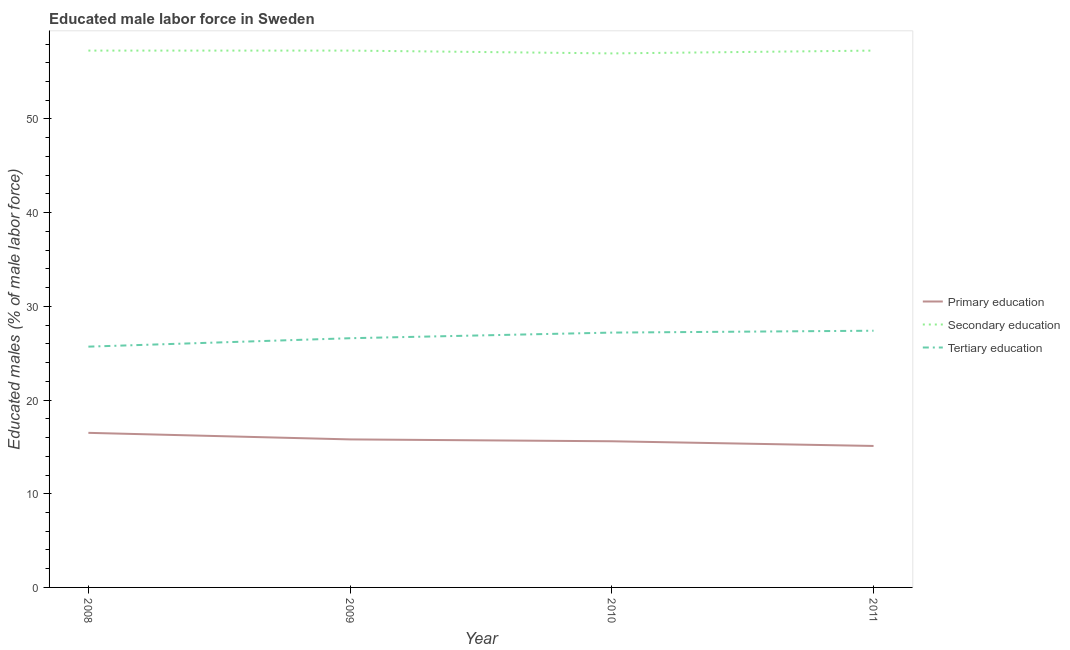Does the line corresponding to percentage of male labor force who received secondary education intersect with the line corresponding to percentage of male labor force who received primary education?
Offer a terse response. No. What is the percentage of male labor force who received secondary education in 2011?
Keep it short and to the point. 57.3. Across all years, what is the minimum percentage of male labor force who received primary education?
Your answer should be very brief. 15.1. In which year was the percentage of male labor force who received tertiary education maximum?
Offer a very short reply. 2011. In which year was the percentage of male labor force who received tertiary education minimum?
Keep it short and to the point. 2008. What is the total percentage of male labor force who received secondary education in the graph?
Offer a very short reply. 228.9. What is the difference between the percentage of male labor force who received secondary education in 2009 and that in 2010?
Provide a succinct answer. 0.3. What is the difference between the percentage of male labor force who received tertiary education in 2008 and the percentage of male labor force who received primary education in 2009?
Keep it short and to the point. 9.9. What is the average percentage of male labor force who received tertiary education per year?
Ensure brevity in your answer.  26.73. In the year 2010, what is the difference between the percentage of male labor force who received tertiary education and percentage of male labor force who received primary education?
Give a very brief answer. 11.6. In how many years, is the percentage of male labor force who received primary education greater than 32 %?
Provide a short and direct response. 0. What is the ratio of the percentage of male labor force who received secondary education in 2009 to that in 2010?
Provide a succinct answer. 1.01. Is the percentage of male labor force who received tertiary education in 2008 less than that in 2009?
Provide a short and direct response. Yes. Is the difference between the percentage of male labor force who received secondary education in 2009 and 2011 greater than the difference between the percentage of male labor force who received primary education in 2009 and 2011?
Your answer should be compact. No. What is the difference between the highest and the second highest percentage of male labor force who received tertiary education?
Provide a succinct answer. 0.2. What is the difference between the highest and the lowest percentage of male labor force who received primary education?
Your answer should be very brief. 1.4. Is the sum of the percentage of male labor force who received secondary education in 2009 and 2011 greater than the maximum percentage of male labor force who received primary education across all years?
Offer a very short reply. Yes. Does the percentage of male labor force who received secondary education monotonically increase over the years?
Your response must be concise. No. Is the percentage of male labor force who received secondary education strictly greater than the percentage of male labor force who received primary education over the years?
Your answer should be compact. Yes. Is the percentage of male labor force who received secondary education strictly less than the percentage of male labor force who received tertiary education over the years?
Make the answer very short. No. What is the difference between two consecutive major ticks on the Y-axis?
Your response must be concise. 10. Are the values on the major ticks of Y-axis written in scientific E-notation?
Give a very brief answer. No. Does the graph contain any zero values?
Ensure brevity in your answer.  No. Does the graph contain grids?
Give a very brief answer. No. Where does the legend appear in the graph?
Your answer should be very brief. Center right. How many legend labels are there?
Your answer should be compact. 3. How are the legend labels stacked?
Ensure brevity in your answer.  Vertical. What is the title of the graph?
Offer a terse response. Educated male labor force in Sweden. Does "Ores and metals" appear as one of the legend labels in the graph?
Your answer should be compact. No. What is the label or title of the Y-axis?
Offer a terse response. Educated males (% of male labor force). What is the Educated males (% of male labor force) in Secondary education in 2008?
Ensure brevity in your answer.  57.3. What is the Educated males (% of male labor force) of Tertiary education in 2008?
Ensure brevity in your answer.  25.7. What is the Educated males (% of male labor force) of Primary education in 2009?
Offer a very short reply. 15.8. What is the Educated males (% of male labor force) in Secondary education in 2009?
Your answer should be compact. 57.3. What is the Educated males (% of male labor force) in Tertiary education in 2009?
Make the answer very short. 26.6. What is the Educated males (% of male labor force) in Primary education in 2010?
Your answer should be very brief. 15.6. What is the Educated males (% of male labor force) of Tertiary education in 2010?
Keep it short and to the point. 27.2. What is the Educated males (% of male labor force) in Primary education in 2011?
Offer a very short reply. 15.1. What is the Educated males (% of male labor force) of Secondary education in 2011?
Provide a short and direct response. 57.3. What is the Educated males (% of male labor force) in Tertiary education in 2011?
Provide a short and direct response. 27.4. Across all years, what is the maximum Educated males (% of male labor force) of Secondary education?
Your answer should be very brief. 57.3. Across all years, what is the maximum Educated males (% of male labor force) of Tertiary education?
Make the answer very short. 27.4. Across all years, what is the minimum Educated males (% of male labor force) in Primary education?
Provide a short and direct response. 15.1. Across all years, what is the minimum Educated males (% of male labor force) of Tertiary education?
Offer a very short reply. 25.7. What is the total Educated males (% of male labor force) of Secondary education in the graph?
Keep it short and to the point. 228.9. What is the total Educated males (% of male labor force) of Tertiary education in the graph?
Offer a very short reply. 106.9. What is the difference between the Educated males (% of male labor force) of Primary education in 2008 and that in 2009?
Keep it short and to the point. 0.7. What is the difference between the Educated males (% of male labor force) of Secondary education in 2008 and that in 2009?
Offer a terse response. 0. What is the difference between the Educated males (% of male labor force) in Secondary education in 2008 and that in 2010?
Offer a terse response. 0.3. What is the difference between the Educated males (% of male labor force) of Tertiary education in 2008 and that in 2010?
Make the answer very short. -1.5. What is the difference between the Educated males (% of male labor force) of Secondary education in 2008 and that in 2011?
Keep it short and to the point. 0. What is the difference between the Educated males (% of male labor force) in Tertiary education in 2008 and that in 2011?
Make the answer very short. -1.7. What is the difference between the Educated males (% of male labor force) in Tertiary education in 2009 and that in 2010?
Keep it short and to the point. -0.6. What is the difference between the Educated males (% of male labor force) of Primary education in 2009 and that in 2011?
Give a very brief answer. 0.7. What is the difference between the Educated males (% of male labor force) in Tertiary education in 2009 and that in 2011?
Your response must be concise. -0.8. What is the difference between the Educated males (% of male labor force) of Tertiary education in 2010 and that in 2011?
Your response must be concise. -0.2. What is the difference between the Educated males (% of male labor force) of Primary education in 2008 and the Educated males (% of male labor force) of Secondary education in 2009?
Give a very brief answer. -40.8. What is the difference between the Educated males (% of male labor force) of Secondary education in 2008 and the Educated males (% of male labor force) of Tertiary education in 2009?
Give a very brief answer. 30.7. What is the difference between the Educated males (% of male labor force) of Primary education in 2008 and the Educated males (% of male labor force) of Secondary education in 2010?
Make the answer very short. -40.5. What is the difference between the Educated males (% of male labor force) in Primary education in 2008 and the Educated males (% of male labor force) in Tertiary education in 2010?
Your answer should be compact. -10.7. What is the difference between the Educated males (% of male labor force) of Secondary education in 2008 and the Educated males (% of male labor force) of Tertiary education in 2010?
Offer a very short reply. 30.1. What is the difference between the Educated males (% of male labor force) in Primary education in 2008 and the Educated males (% of male labor force) in Secondary education in 2011?
Give a very brief answer. -40.8. What is the difference between the Educated males (% of male labor force) in Secondary education in 2008 and the Educated males (% of male labor force) in Tertiary education in 2011?
Your answer should be very brief. 29.9. What is the difference between the Educated males (% of male labor force) of Primary education in 2009 and the Educated males (% of male labor force) of Secondary education in 2010?
Give a very brief answer. -41.2. What is the difference between the Educated males (% of male labor force) of Secondary education in 2009 and the Educated males (% of male labor force) of Tertiary education in 2010?
Provide a succinct answer. 30.1. What is the difference between the Educated males (% of male labor force) of Primary education in 2009 and the Educated males (% of male labor force) of Secondary education in 2011?
Keep it short and to the point. -41.5. What is the difference between the Educated males (% of male labor force) in Primary education in 2009 and the Educated males (% of male labor force) in Tertiary education in 2011?
Your response must be concise. -11.6. What is the difference between the Educated males (% of male labor force) of Secondary education in 2009 and the Educated males (% of male labor force) of Tertiary education in 2011?
Make the answer very short. 29.9. What is the difference between the Educated males (% of male labor force) of Primary education in 2010 and the Educated males (% of male labor force) of Secondary education in 2011?
Your response must be concise. -41.7. What is the difference between the Educated males (% of male labor force) in Primary education in 2010 and the Educated males (% of male labor force) in Tertiary education in 2011?
Offer a very short reply. -11.8. What is the difference between the Educated males (% of male labor force) in Secondary education in 2010 and the Educated males (% of male labor force) in Tertiary education in 2011?
Make the answer very short. 29.6. What is the average Educated males (% of male labor force) in Primary education per year?
Provide a succinct answer. 15.75. What is the average Educated males (% of male labor force) of Secondary education per year?
Give a very brief answer. 57.23. What is the average Educated males (% of male labor force) of Tertiary education per year?
Give a very brief answer. 26.73. In the year 2008, what is the difference between the Educated males (% of male labor force) of Primary education and Educated males (% of male labor force) of Secondary education?
Make the answer very short. -40.8. In the year 2008, what is the difference between the Educated males (% of male labor force) in Secondary education and Educated males (% of male labor force) in Tertiary education?
Provide a short and direct response. 31.6. In the year 2009, what is the difference between the Educated males (% of male labor force) in Primary education and Educated males (% of male labor force) in Secondary education?
Make the answer very short. -41.5. In the year 2009, what is the difference between the Educated males (% of male labor force) of Secondary education and Educated males (% of male labor force) of Tertiary education?
Your answer should be very brief. 30.7. In the year 2010, what is the difference between the Educated males (% of male labor force) in Primary education and Educated males (% of male labor force) in Secondary education?
Give a very brief answer. -41.4. In the year 2010, what is the difference between the Educated males (% of male labor force) in Secondary education and Educated males (% of male labor force) in Tertiary education?
Provide a short and direct response. 29.8. In the year 2011, what is the difference between the Educated males (% of male labor force) in Primary education and Educated males (% of male labor force) in Secondary education?
Make the answer very short. -42.2. In the year 2011, what is the difference between the Educated males (% of male labor force) of Primary education and Educated males (% of male labor force) of Tertiary education?
Keep it short and to the point. -12.3. In the year 2011, what is the difference between the Educated males (% of male labor force) in Secondary education and Educated males (% of male labor force) in Tertiary education?
Keep it short and to the point. 29.9. What is the ratio of the Educated males (% of male labor force) of Primary education in 2008 to that in 2009?
Give a very brief answer. 1.04. What is the ratio of the Educated males (% of male labor force) in Tertiary education in 2008 to that in 2009?
Make the answer very short. 0.97. What is the ratio of the Educated males (% of male labor force) of Primary education in 2008 to that in 2010?
Offer a terse response. 1.06. What is the ratio of the Educated males (% of male labor force) in Tertiary education in 2008 to that in 2010?
Keep it short and to the point. 0.94. What is the ratio of the Educated males (% of male labor force) in Primary education in 2008 to that in 2011?
Provide a short and direct response. 1.09. What is the ratio of the Educated males (% of male labor force) of Tertiary education in 2008 to that in 2011?
Your answer should be compact. 0.94. What is the ratio of the Educated males (% of male labor force) in Primary education in 2009 to that in 2010?
Keep it short and to the point. 1.01. What is the ratio of the Educated males (% of male labor force) of Tertiary education in 2009 to that in 2010?
Your response must be concise. 0.98. What is the ratio of the Educated males (% of male labor force) of Primary education in 2009 to that in 2011?
Keep it short and to the point. 1.05. What is the ratio of the Educated males (% of male labor force) in Tertiary education in 2009 to that in 2011?
Offer a terse response. 0.97. What is the ratio of the Educated males (% of male labor force) in Primary education in 2010 to that in 2011?
Provide a succinct answer. 1.03. What is the ratio of the Educated males (% of male labor force) of Tertiary education in 2010 to that in 2011?
Offer a terse response. 0.99. What is the difference between the highest and the second highest Educated males (% of male labor force) of Primary education?
Ensure brevity in your answer.  0.7. What is the difference between the highest and the second highest Educated males (% of male labor force) of Secondary education?
Your answer should be compact. 0. What is the difference between the highest and the lowest Educated males (% of male labor force) of Primary education?
Offer a terse response. 1.4. What is the difference between the highest and the lowest Educated males (% of male labor force) in Secondary education?
Provide a short and direct response. 0.3. What is the difference between the highest and the lowest Educated males (% of male labor force) in Tertiary education?
Keep it short and to the point. 1.7. 